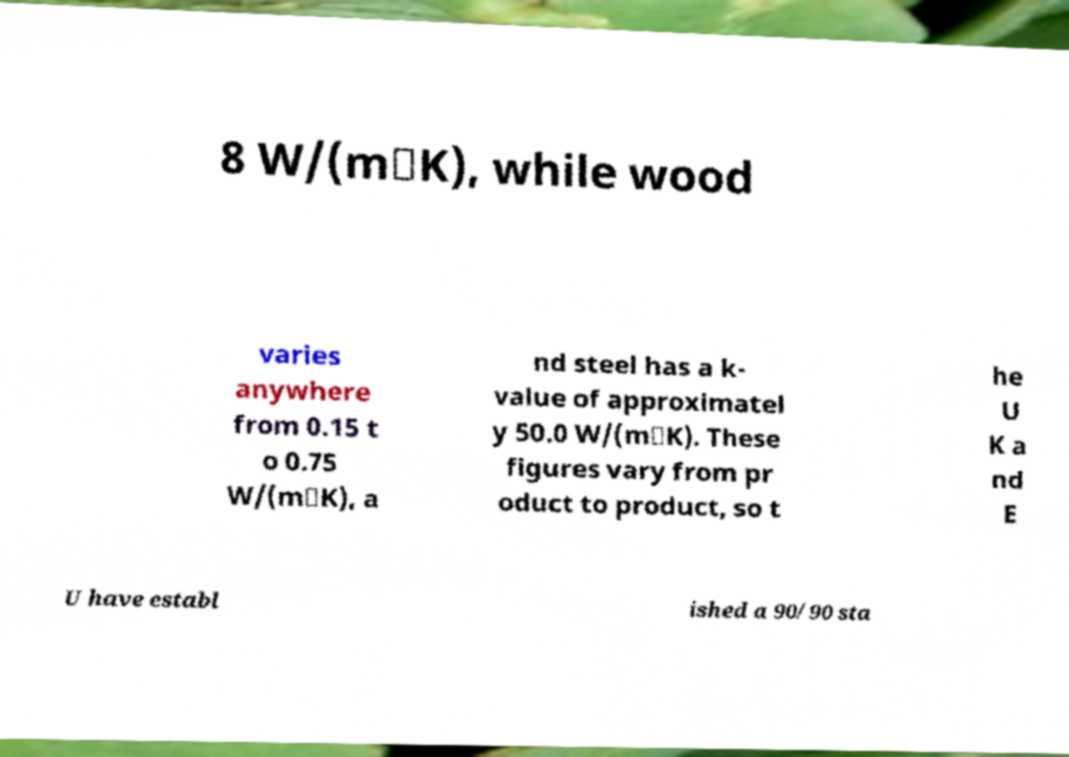Could you assist in decoding the text presented in this image and type it out clearly? 8 W/(m⋅K), while wood varies anywhere from 0.15 t o 0.75 W/(m⋅K), a nd steel has a k- value of approximatel y 50.0 W/(m⋅K). These figures vary from pr oduct to product, so t he U K a nd E U have establ ished a 90/90 sta 